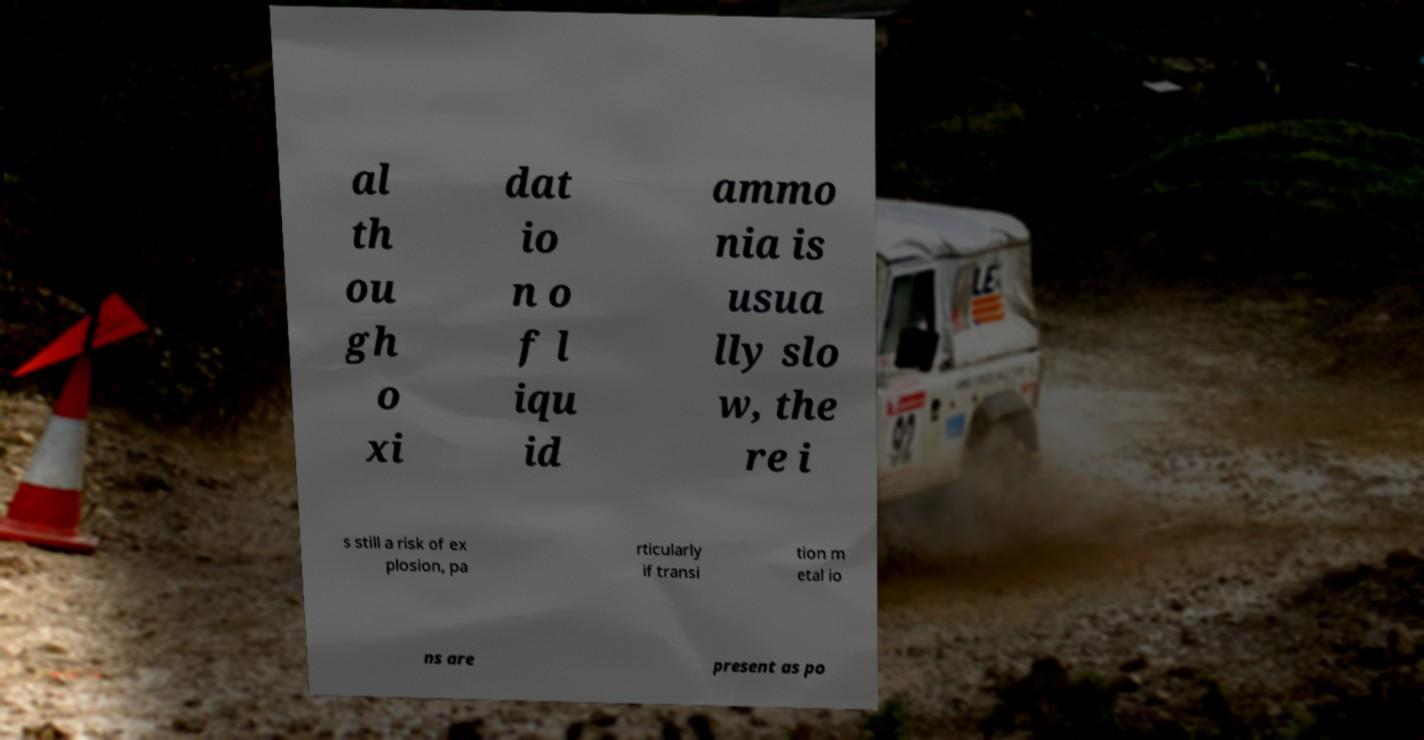Please identify and transcribe the text found in this image. al th ou gh o xi dat io n o f l iqu id ammo nia is usua lly slo w, the re i s still a risk of ex plosion, pa rticularly if transi tion m etal io ns are present as po 